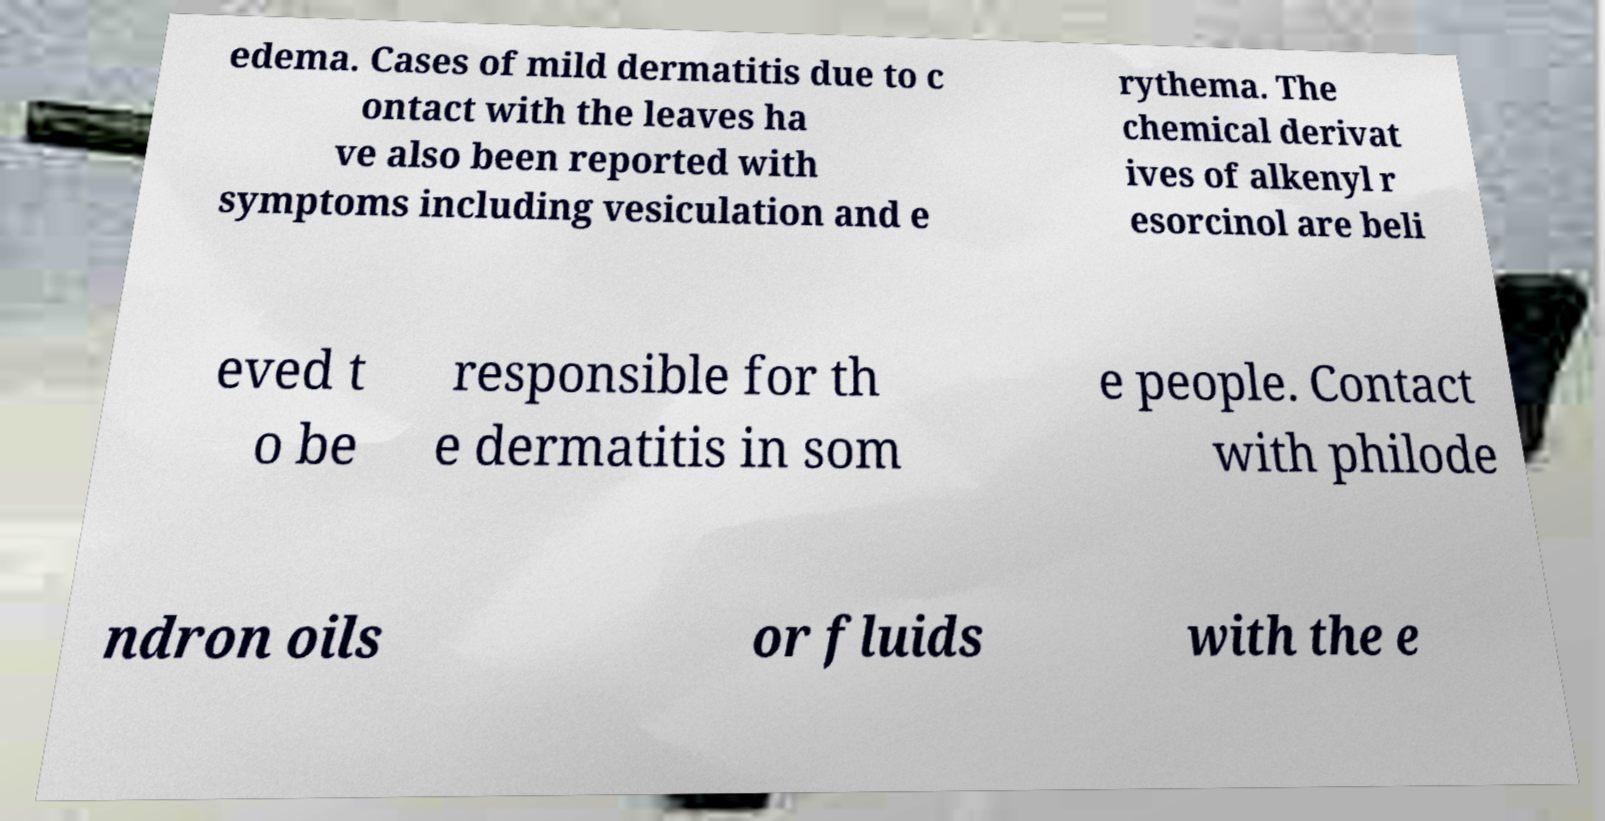Can you read and provide the text displayed in the image?This photo seems to have some interesting text. Can you extract and type it out for me? edema. Cases of mild dermatitis due to c ontact with the leaves ha ve also been reported with symptoms including vesiculation and e rythema. The chemical derivat ives of alkenyl r esorcinol are beli eved t o be responsible for th e dermatitis in som e people. Contact with philode ndron oils or fluids with the e 